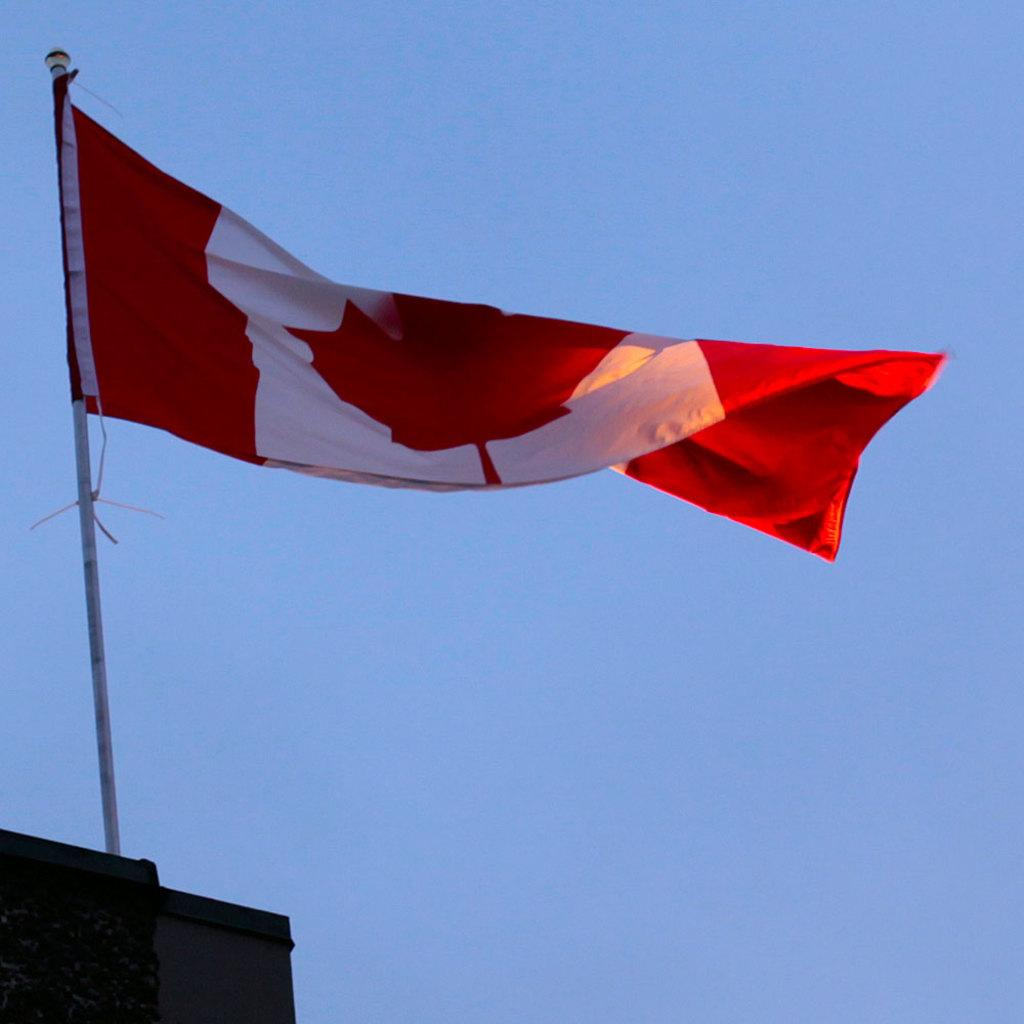What is located on the building in the image? There is a flag on a building in the image. What is visible at the top of the image? The sky is visible at the top of the image. What type of muscle can be seen flexing in the image? There is no muscle present in the image. How many crates are visible in the image? There are no crates present in the image. 